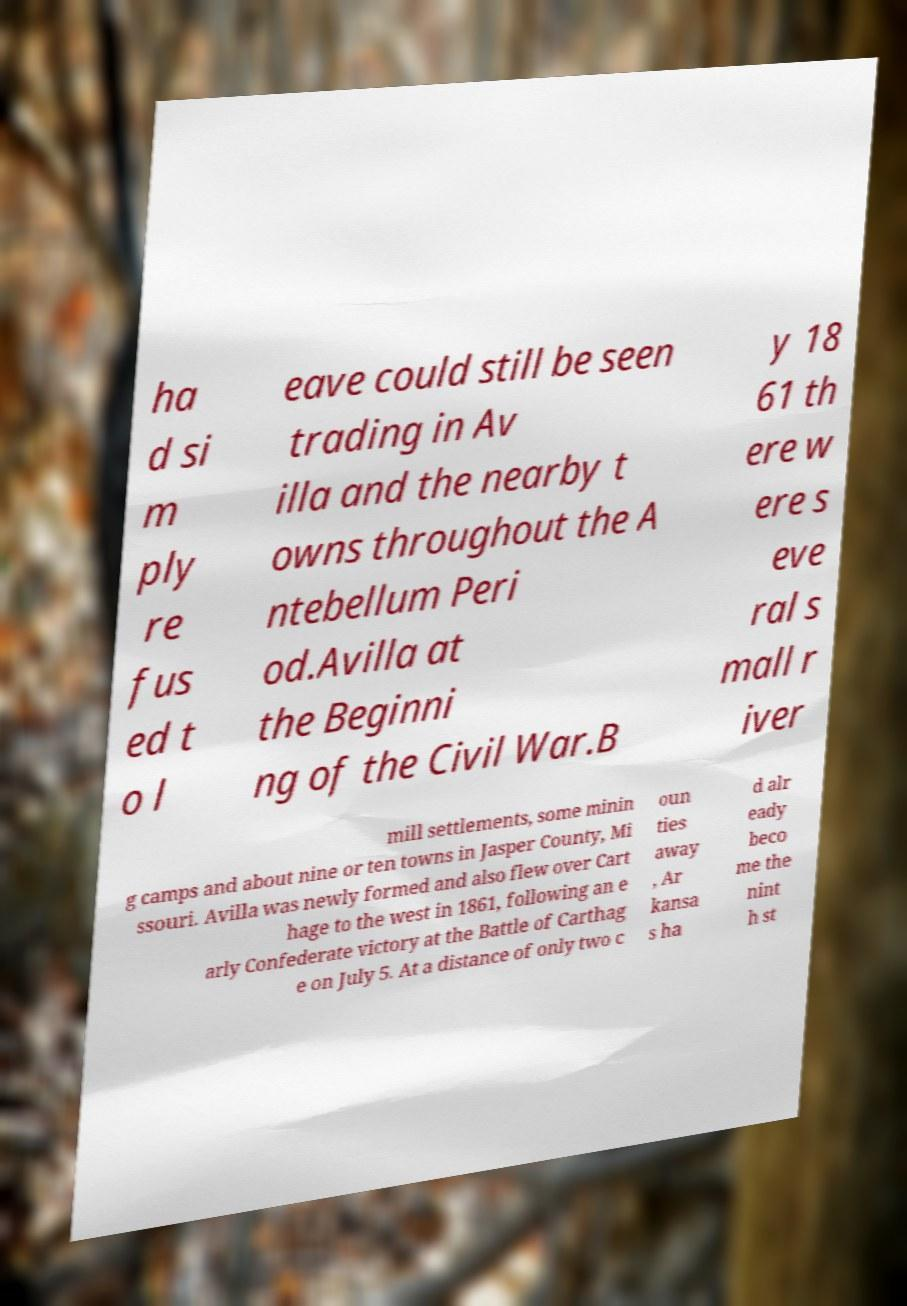Can you read and provide the text displayed in the image?This photo seems to have some interesting text. Can you extract and type it out for me? ha d si m ply re fus ed t o l eave could still be seen trading in Av illa and the nearby t owns throughout the A ntebellum Peri od.Avilla at the Beginni ng of the Civil War.B y 18 61 th ere w ere s eve ral s mall r iver mill settlements, some minin g camps and about nine or ten towns in Jasper County, Mi ssouri. Avilla was newly formed and also flew over Cart hage to the west in 1861, following an e arly Confederate victory at the Battle of Carthag e on July 5. At a distance of only two c oun ties away , Ar kansa s ha d alr eady beco me the nint h st 